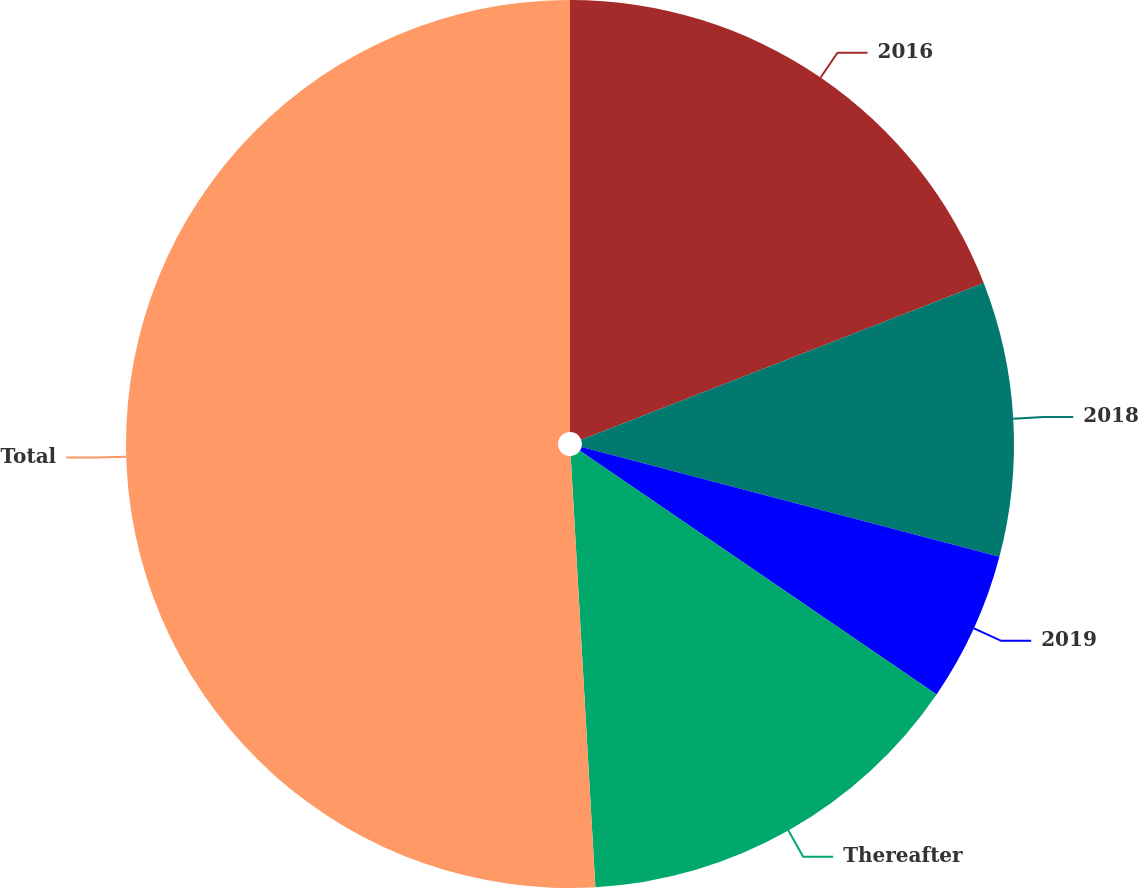Convert chart. <chart><loc_0><loc_0><loc_500><loc_500><pie_chart><fcel>2016<fcel>2018<fcel>2019<fcel>Thereafter<fcel>Total<nl><fcel>19.09%<fcel>10.0%<fcel>5.45%<fcel>14.55%<fcel>50.91%<nl></chart> 